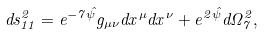<formula> <loc_0><loc_0><loc_500><loc_500>d s _ { 1 1 } ^ { 2 } = e ^ { - 7 \hat { \psi } } g _ { \mu \nu } d x ^ { \mu } d x ^ { \nu } + e ^ { 2 \hat { \psi } } d \Omega _ { 7 } ^ { 2 } ,</formula> 